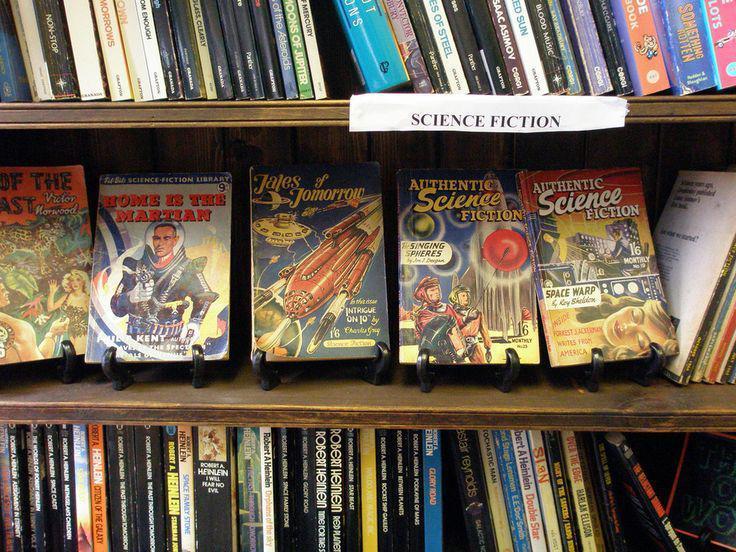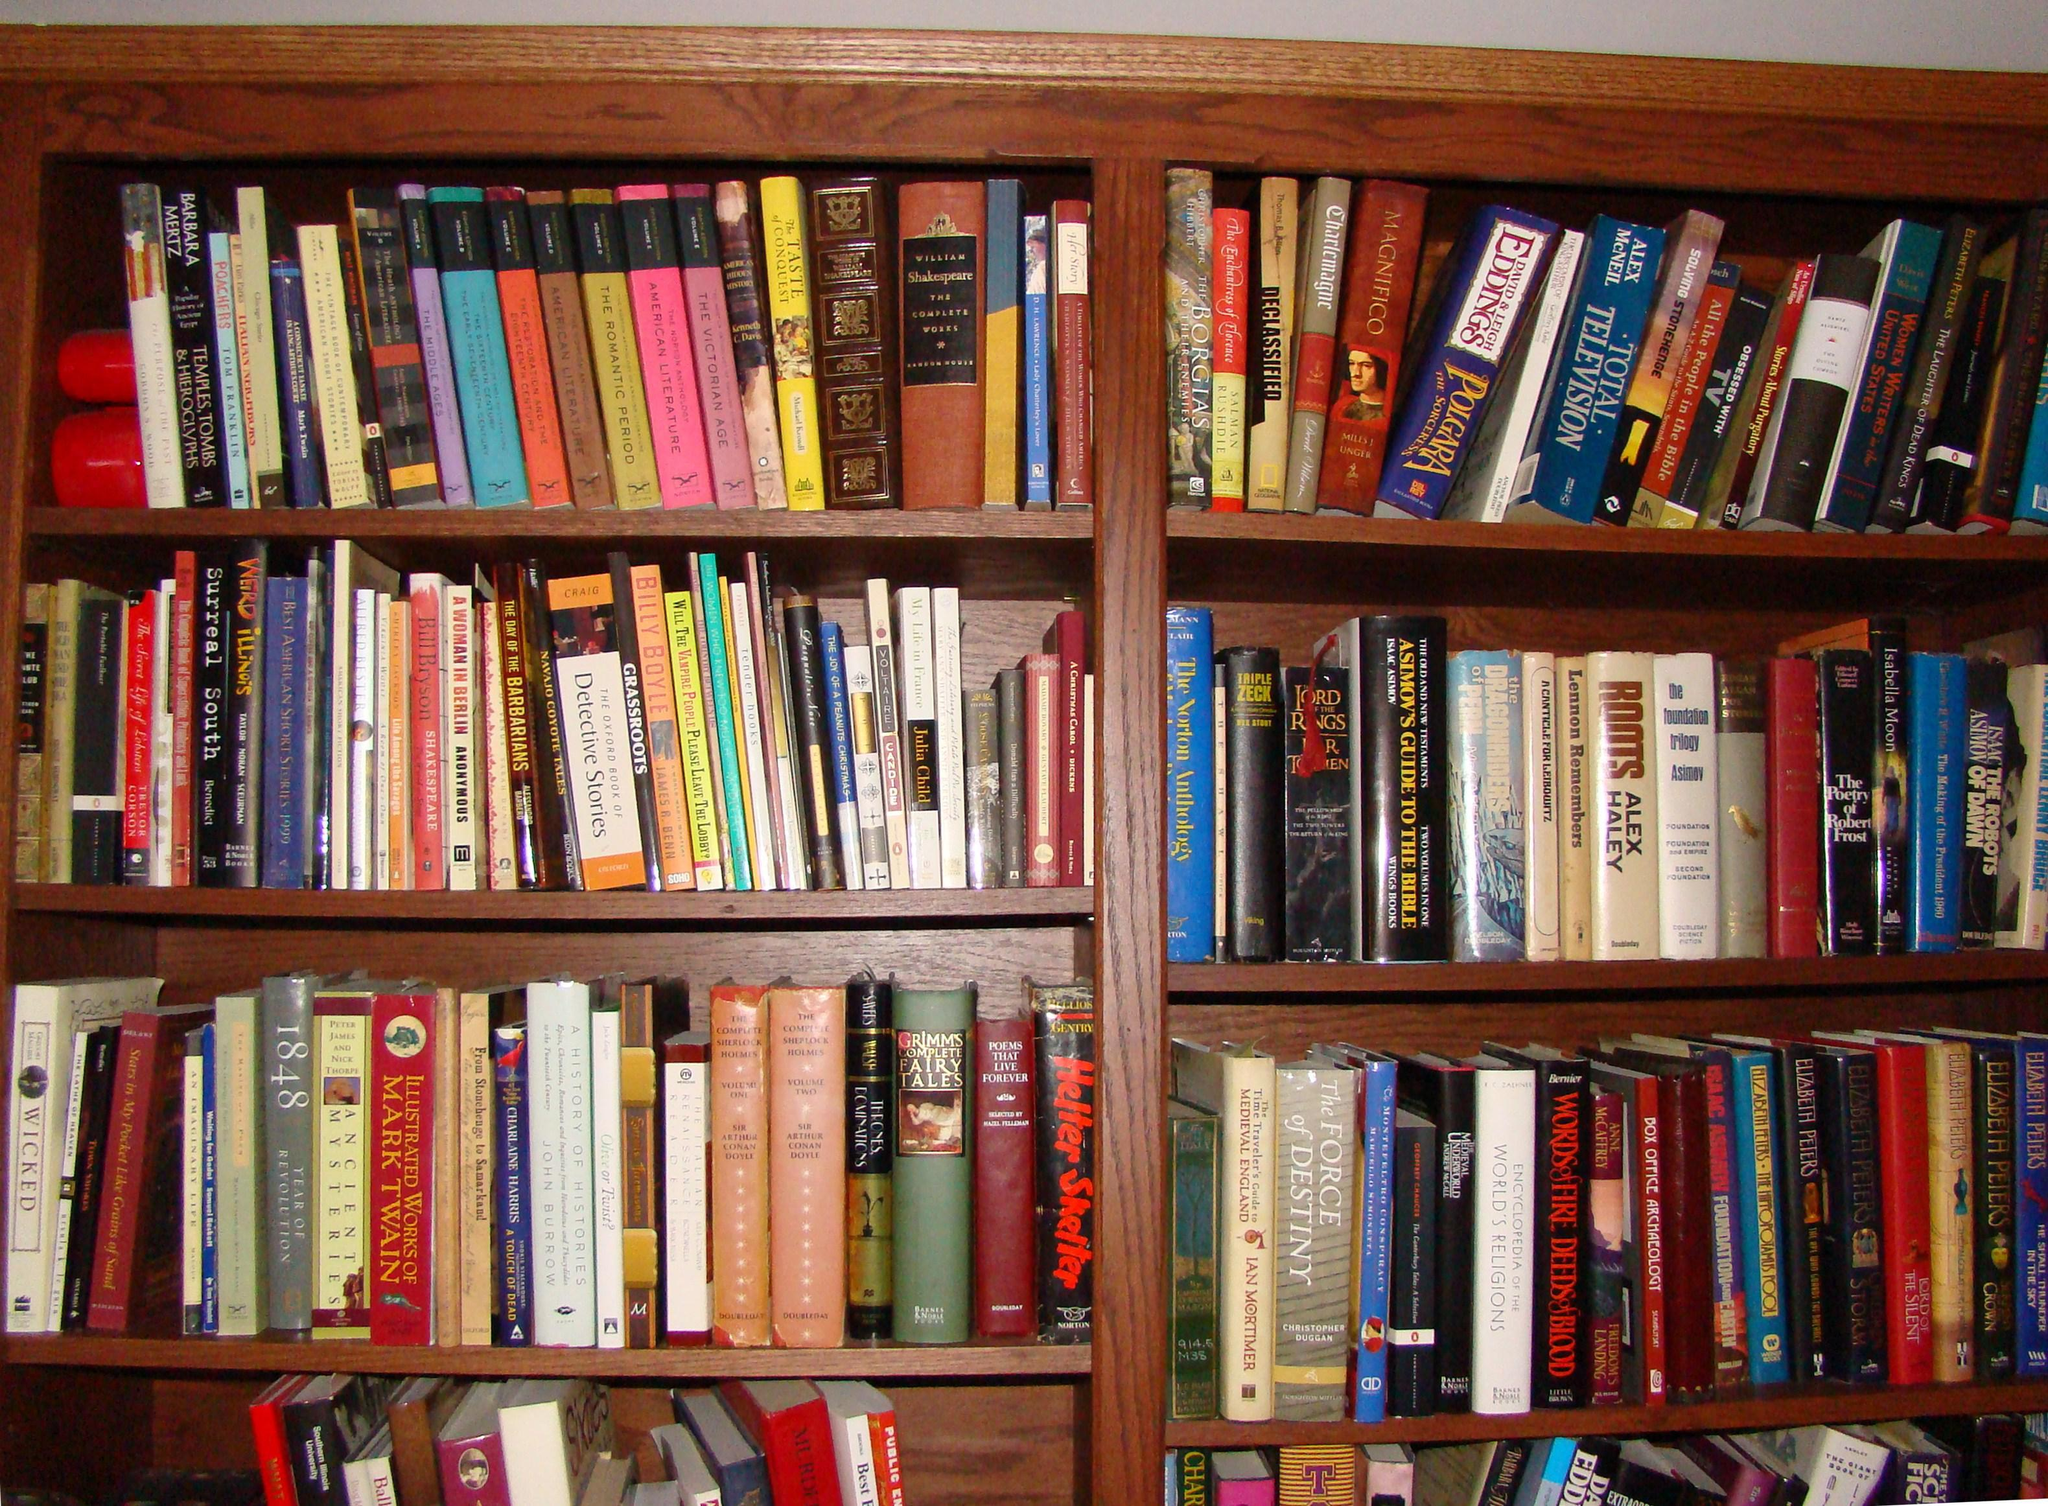The first image is the image on the left, the second image is the image on the right. Analyze the images presented: Is the assertion "The right image shows no more than six shelves of books and no shelves have white labels on their edges." valid? Answer yes or no. Yes. 